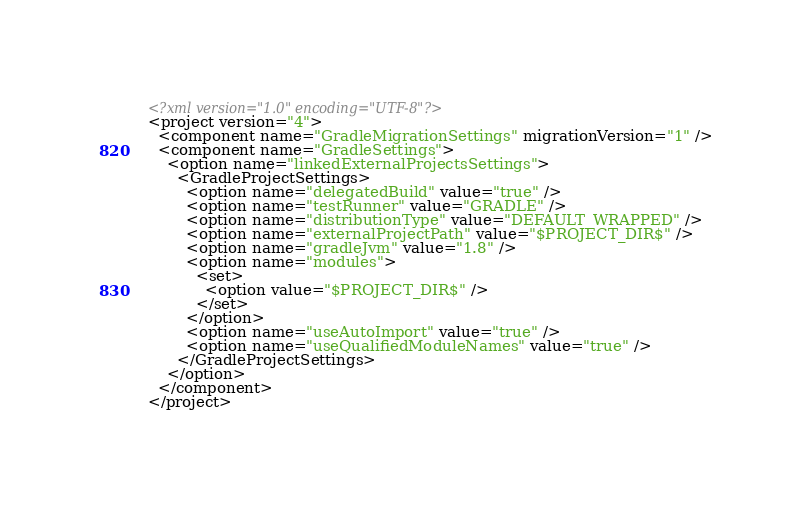<code> <loc_0><loc_0><loc_500><loc_500><_XML_><?xml version="1.0" encoding="UTF-8"?>
<project version="4">
  <component name="GradleMigrationSettings" migrationVersion="1" />
  <component name="GradleSettings">
    <option name="linkedExternalProjectsSettings">
      <GradleProjectSettings>
        <option name="delegatedBuild" value="true" />
        <option name="testRunner" value="GRADLE" />
        <option name="distributionType" value="DEFAULT_WRAPPED" />
        <option name="externalProjectPath" value="$PROJECT_DIR$" />
        <option name="gradleJvm" value="1.8" />
        <option name="modules">
          <set>
            <option value="$PROJECT_DIR$" />
          </set>
        </option>
        <option name="useAutoImport" value="true" />
        <option name="useQualifiedModuleNames" value="true" />
      </GradleProjectSettings>
    </option>
  </component>
</project></code> 